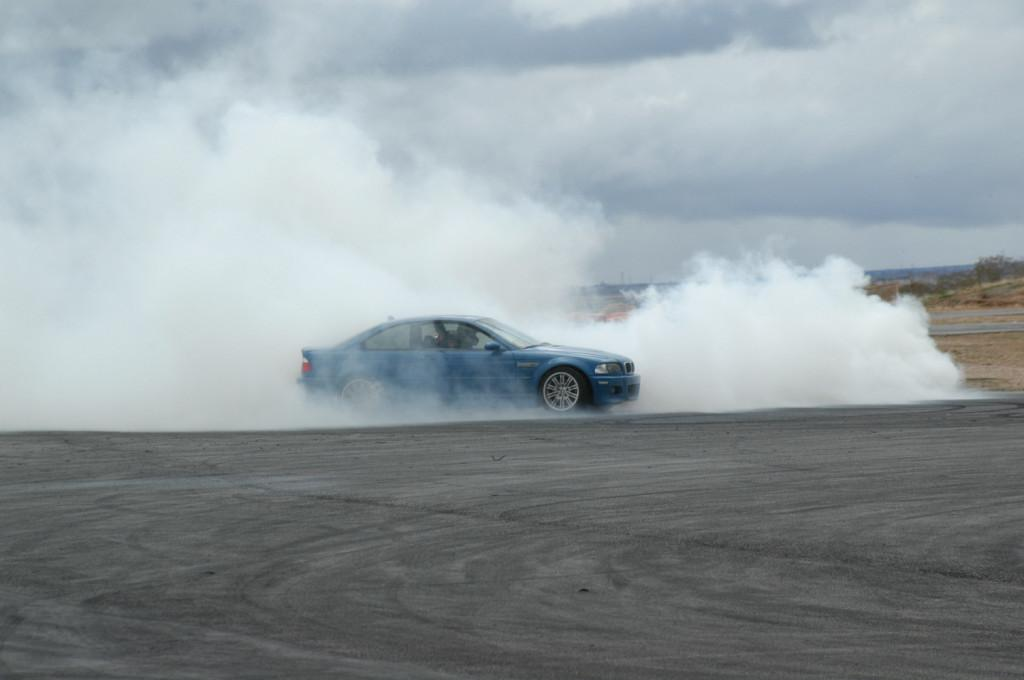What color is the car in the image? The car in the image is blue. Where is the car located in the image? The car is on the road in the image. What can be seen coming from the car in the image? There is smoke visible in the image. What type of natural vegetation is present in the image? There are trees in the image. How would you describe the color of the sky in the image? The sky is a combination of white and blue colors in the image. What type of cracker is being used to control the smoke in the image? There is no cracker present in the image, and therefore no such activity can be observed. 